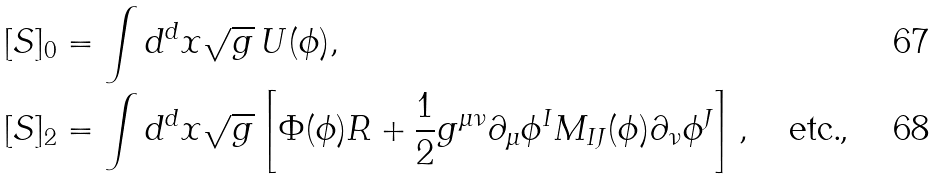<formula> <loc_0><loc_0><loc_500><loc_500>[ S ] _ { 0 } & = \int d ^ { d } x \sqrt { g } \, U ( \phi ) , \\ [ S ] _ { 2 } & = \int d ^ { d } x \sqrt { g } \left [ \Phi ( \phi ) R + \frac { 1 } { 2 } g ^ { \mu \nu } \partial _ { \mu } \phi ^ { I } M _ { I J } ( \phi ) \partial _ { \nu } \phi ^ { J } \right ] , \quad \text {etc.,}</formula> 